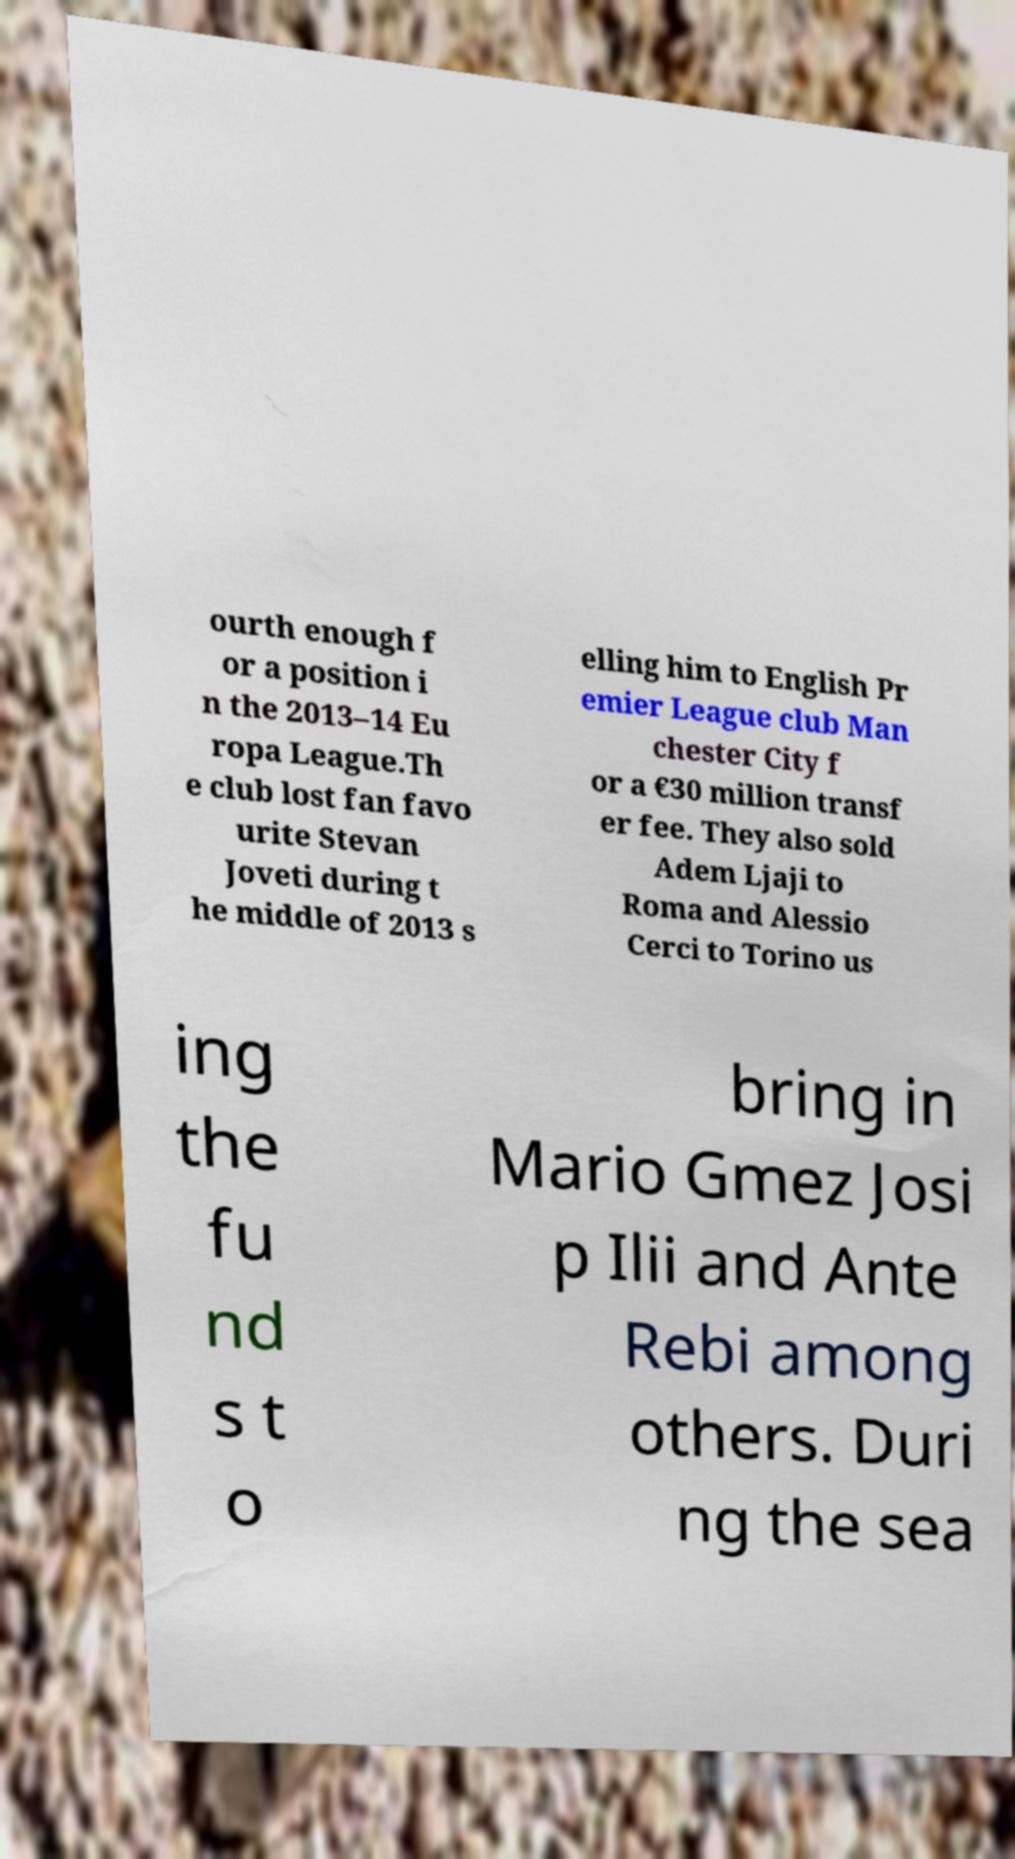I need the written content from this picture converted into text. Can you do that? ourth enough f or a position i n the 2013–14 Eu ropa League.Th e club lost fan favo urite Stevan Joveti during t he middle of 2013 s elling him to English Pr emier League club Man chester City f or a €30 million transf er fee. They also sold Adem Ljaji to Roma and Alessio Cerci to Torino us ing the fu nd s t o bring in Mario Gmez Josi p Ilii and Ante Rebi among others. Duri ng the sea 